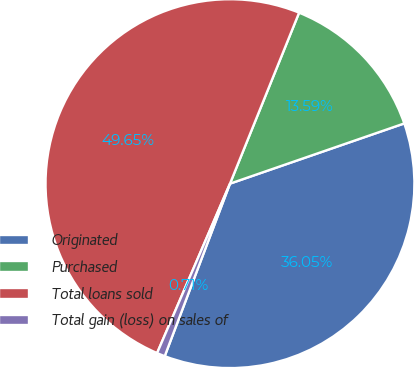Convert chart. <chart><loc_0><loc_0><loc_500><loc_500><pie_chart><fcel>Originated<fcel>Purchased<fcel>Total loans sold<fcel>Total gain (loss) on sales of<nl><fcel>36.05%<fcel>13.59%<fcel>49.65%<fcel>0.71%<nl></chart> 